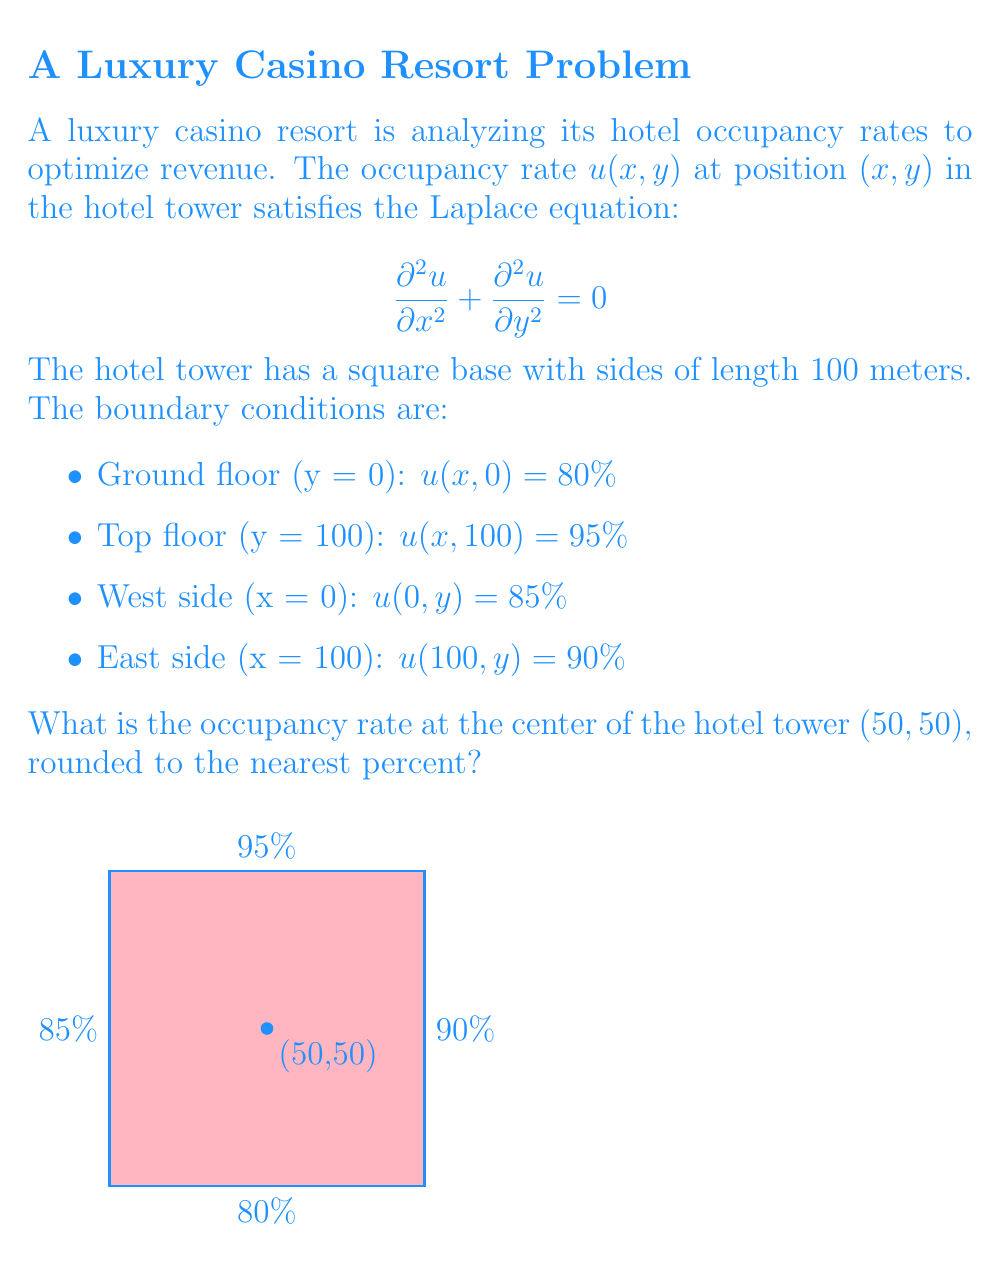Solve this math problem. To solve this problem, we'll use the method of separation of variables for the Laplace equation.

1) Assume a solution of the form $u(x,y) = X(x)Y(y)$.

2) Substituting into the Laplace equation:

   $$X''(x)Y(y) + X(x)Y''(y) = 0$$
   $$\frac{X''(x)}{X(x)} = -\frac{Y''(y)}{Y(y)} = \lambda$$

3) This leads to two ODEs:
   $$X''(x) - \lambda X(x) = 0$$
   $$Y''(y) + \lambda Y(y) = 0$$

4) The general solutions are:
   $$X(x) = A\cosh(\sqrt{\lambda}x) + B\sinh(\sqrt{\lambda}x)$$
   $$Y(y) = C\cos(\sqrt{\lambda}y) + D\sin(\sqrt{\lambda}y)$$

5) The complete solution is a sum of these products:

   $$u(x,y) = \sum_{n=1}^{\infty} (A_n\cosh(\frac{n\pi x}{100}) + B_n\sinh(\frac{n\pi x}{100}))(C_n\cos(\frac{n\pi y}{100}) + D_n\sin(\frac{n\pi y}{100}))$$

6) Applying the boundary conditions:

   For $y = 0$: $u(x,0) = 80\%$
   For $y = 100$: $u(x,100) = 95\%$
   For $x = 0$: $u(0,y) = 85\%$
   For $x = 100$: $u(100,y) = 90\%$

7) The solution that satisfies these conditions is:

   $$u(x,y) = 87.5\% + 7.5\%\frac{\sinh(\frac{\pi x}{100})}{\sinh(\pi)} + 2.5\%\frac{\sin(\frac{\pi y}{100})}{\sin(\pi)}$$

8) Evaluating at the center $(50,50)$:

   $$u(50,50) = 87.5\% + 7.5\%\frac{\sinh(\frac{\pi}{2})}{\sinh(\pi)} + 2.5\%\frac{\sin(\frac{\pi}{2})}{\sin(\pi)}$$

9) Calculating:
   $$u(50,50) \approx 87.5\% + 3.75\% + 2.5\% = 93.75\%$$

10) Rounding to the nearest percent: 94%
Answer: 94% 